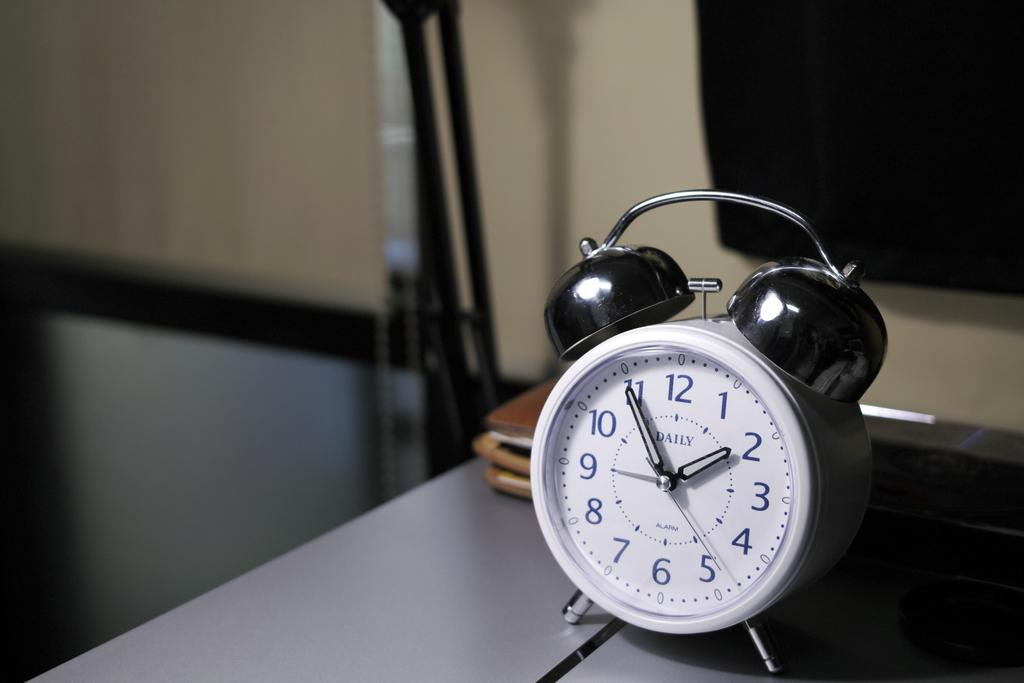<image>
Create a compact narrative representing the image presented. A silver alarm clock sitting on a table showing the time as 2 o'clock. 